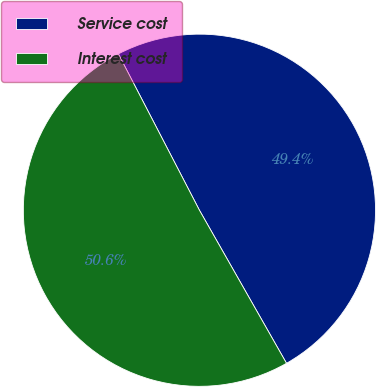Convert chart to OTSL. <chart><loc_0><loc_0><loc_500><loc_500><pie_chart><fcel>Service cost<fcel>Interest cost<nl><fcel>49.38%<fcel>50.62%<nl></chart> 